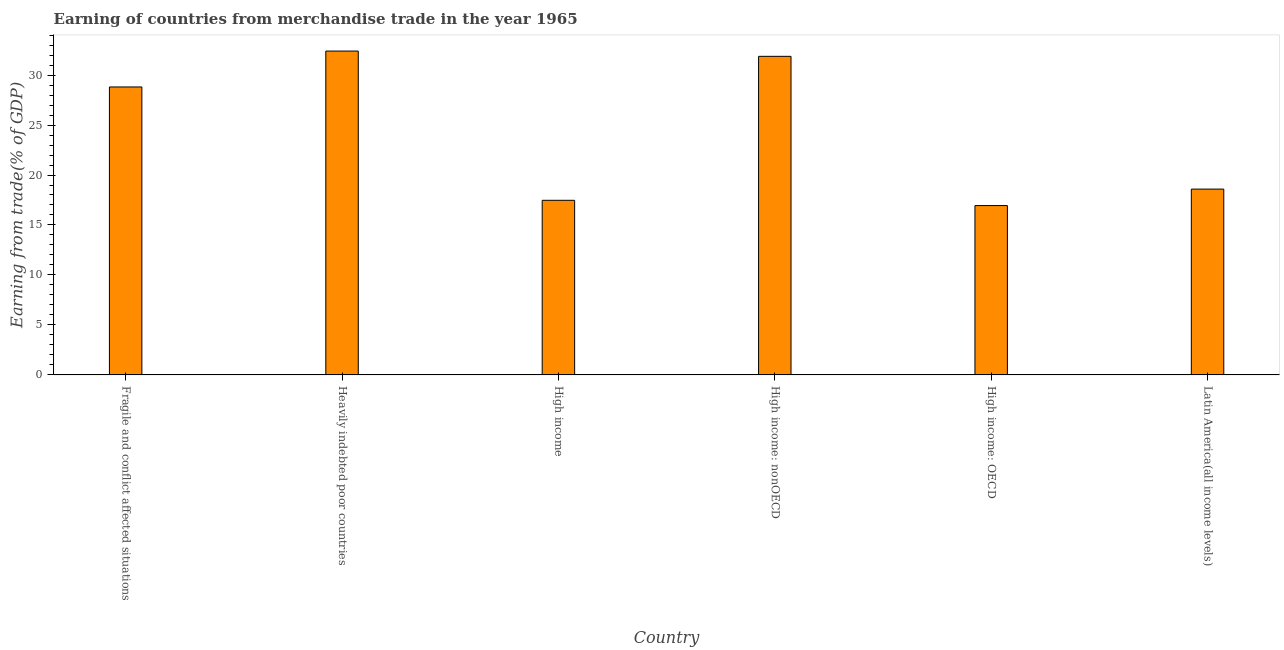Does the graph contain any zero values?
Provide a succinct answer. No. What is the title of the graph?
Your answer should be very brief. Earning of countries from merchandise trade in the year 1965. What is the label or title of the Y-axis?
Make the answer very short. Earning from trade(% of GDP). What is the earning from merchandise trade in Fragile and conflict affected situations?
Your answer should be very brief. 28.81. Across all countries, what is the maximum earning from merchandise trade?
Your response must be concise. 32.4. Across all countries, what is the minimum earning from merchandise trade?
Your answer should be compact. 16.94. In which country was the earning from merchandise trade maximum?
Ensure brevity in your answer.  Heavily indebted poor countries. In which country was the earning from merchandise trade minimum?
Provide a short and direct response. High income: OECD. What is the sum of the earning from merchandise trade?
Your response must be concise. 146.08. What is the difference between the earning from merchandise trade in Fragile and conflict affected situations and High income?
Keep it short and to the point. 11.34. What is the average earning from merchandise trade per country?
Make the answer very short. 24.35. What is the median earning from merchandise trade?
Provide a short and direct response. 23.7. What is the ratio of the earning from merchandise trade in Fragile and conflict affected situations to that in Latin America(all income levels)?
Offer a terse response. 1.55. Is the earning from merchandise trade in Fragile and conflict affected situations less than that in High income: nonOECD?
Ensure brevity in your answer.  Yes. What is the difference between the highest and the second highest earning from merchandise trade?
Offer a terse response. 0.53. Is the sum of the earning from merchandise trade in Fragile and conflict affected situations and High income: OECD greater than the maximum earning from merchandise trade across all countries?
Provide a short and direct response. Yes. What is the difference between the highest and the lowest earning from merchandise trade?
Your response must be concise. 15.46. How many bars are there?
Offer a very short reply. 6. What is the difference between two consecutive major ticks on the Y-axis?
Your answer should be compact. 5. Are the values on the major ticks of Y-axis written in scientific E-notation?
Offer a very short reply. No. What is the Earning from trade(% of GDP) of Fragile and conflict affected situations?
Provide a succinct answer. 28.81. What is the Earning from trade(% of GDP) of Heavily indebted poor countries?
Offer a very short reply. 32.4. What is the Earning from trade(% of GDP) in High income?
Provide a short and direct response. 17.47. What is the Earning from trade(% of GDP) in High income: nonOECD?
Your response must be concise. 31.87. What is the Earning from trade(% of GDP) of High income: OECD?
Make the answer very short. 16.94. What is the Earning from trade(% of GDP) in Latin America(all income levels)?
Your response must be concise. 18.59. What is the difference between the Earning from trade(% of GDP) in Fragile and conflict affected situations and Heavily indebted poor countries?
Your answer should be very brief. -3.59. What is the difference between the Earning from trade(% of GDP) in Fragile and conflict affected situations and High income?
Offer a terse response. 11.34. What is the difference between the Earning from trade(% of GDP) in Fragile and conflict affected situations and High income: nonOECD?
Provide a succinct answer. -3.06. What is the difference between the Earning from trade(% of GDP) in Fragile and conflict affected situations and High income: OECD?
Provide a short and direct response. 11.87. What is the difference between the Earning from trade(% of GDP) in Fragile and conflict affected situations and Latin America(all income levels)?
Provide a short and direct response. 10.22. What is the difference between the Earning from trade(% of GDP) in Heavily indebted poor countries and High income?
Make the answer very short. 14.93. What is the difference between the Earning from trade(% of GDP) in Heavily indebted poor countries and High income: nonOECD?
Your answer should be compact. 0.53. What is the difference between the Earning from trade(% of GDP) in Heavily indebted poor countries and High income: OECD?
Your answer should be very brief. 15.46. What is the difference between the Earning from trade(% of GDP) in Heavily indebted poor countries and Latin America(all income levels)?
Keep it short and to the point. 13.81. What is the difference between the Earning from trade(% of GDP) in High income and High income: nonOECD?
Keep it short and to the point. -14.4. What is the difference between the Earning from trade(% of GDP) in High income and High income: OECD?
Provide a succinct answer. 0.53. What is the difference between the Earning from trade(% of GDP) in High income and Latin America(all income levels)?
Your answer should be very brief. -1.12. What is the difference between the Earning from trade(% of GDP) in High income: nonOECD and High income: OECD?
Your answer should be compact. 14.93. What is the difference between the Earning from trade(% of GDP) in High income: nonOECD and Latin America(all income levels)?
Your response must be concise. 13.28. What is the difference between the Earning from trade(% of GDP) in High income: OECD and Latin America(all income levels)?
Ensure brevity in your answer.  -1.65. What is the ratio of the Earning from trade(% of GDP) in Fragile and conflict affected situations to that in Heavily indebted poor countries?
Your response must be concise. 0.89. What is the ratio of the Earning from trade(% of GDP) in Fragile and conflict affected situations to that in High income?
Your response must be concise. 1.65. What is the ratio of the Earning from trade(% of GDP) in Fragile and conflict affected situations to that in High income: nonOECD?
Your answer should be very brief. 0.9. What is the ratio of the Earning from trade(% of GDP) in Fragile and conflict affected situations to that in High income: OECD?
Make the answer very short. 1.7. What is the ratio of the Earning from trade(% of GDP) in Fragile and conflict affected situations to that in Latin America(all income levels)?
Provide a short and direct response. 1.55. What is the ratio of the Earning from trade(% of GDP) in Heavily indebted poor countries to that in High income?
Keep it short and to the point. 1.85. What is the ratio of the Earning from trade(% of GDP) in Heavily indebted poor countries to that in High income: OECD?
Provide a short and direct response. 1.91. What is the ratio of the Earning from trade(% of GDP) in Heavily indebted poor countries to that in Latin America(all income levels)?
Give a very brief answer. 1.74. What is the ratio of the Earning from trade(% of GDP) in High income to that in High income: nonOECD?
Provide a succinct answer. 0.55. What is the ratio of the Earning from trade(% of GDP) in High income to that in High income: OECD?
Your response must be concise. 1.03. What is the ratio of the Earning from trade(% of GDP) in High income to that in Latin America(all income levels)?
Ensure brevity in your answer.  0.94. What is the ratio of the Earning from trade(% of GDP) in High income: nonOECD to that in High income: OECD?
Provide a short and direct response. 1.88. What is the ratio of the Earning from trade(% of GDP) in High income: nonOECD to that in Latin America(all income levels)?
Your answer should be very brief. 1.72. What is the ratio of the Earning from trade(% of GDP) in High income: OECD to that in Latin America(all income levels)?
Your answer should be compact. 0.91. 